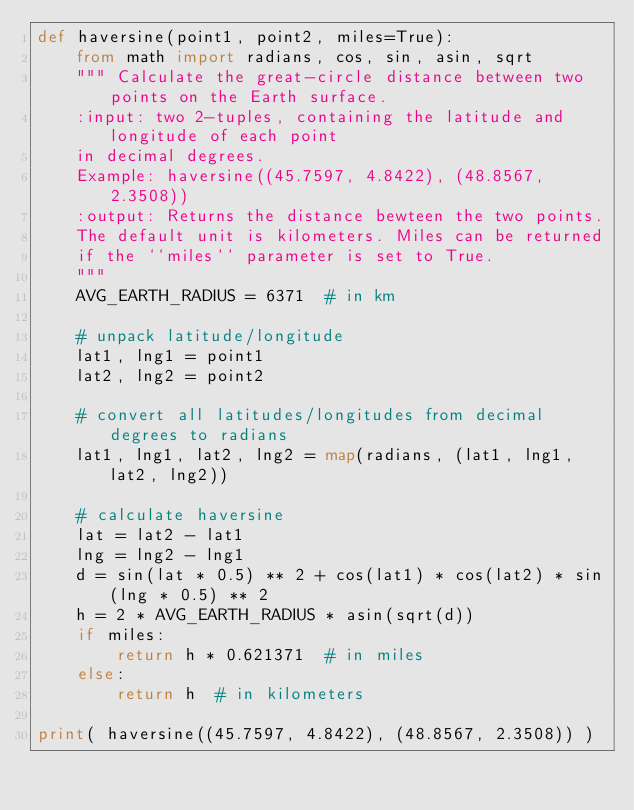Convert code to text. <code><loc_0><loc_0><loc_500><loc_500><_Python_>def haversine(point1, point2, miles=True):
    from math import radians, cos, sin, asin, sqrt
    """ Calculate the great-circle distance between two points on the Earth surface.
    :input: two 2-tuples, containing the latitude and longitude of each point
    in decimal degrees.
    Example: haversine((45.7597, 4.8422), (48.8567, 2.3508))
    :output: Returns the distance bewteen the two points.
    The default unit is kilometers. Miles can be returned
    if the ``miles`` parameter is set to True.
    """
    AVG_EARTH_RADIUS = 6371  # in km

    # unpack latitude/longitude
    lat1, lng1 = point1
    lat2, lng2 = point2

    # convert all latitudes/longitudes from decimal degrees to radians
    lat1, lng1, lat2, lng2 = map(radians, (lat1, lng1, lat2, lng2))

    # calculate haversine
    lat = lat2 - lat1
    lng = lng2 - lng1
    d = sin(lat * 0.5) ** 2 + cos(lat1) * cos(lat2) * sin(lng * 0.5) ** 2
    h = 2 * AVG_EARTH_RADIUS * asin(sqrt(d))
    if miles:
        return h * 0.621371  # in miles
    else:
        return h  # in kilometers

print( haversine((45.7597, 4.8422), (48.8567, 2.3508)) )
</code> 